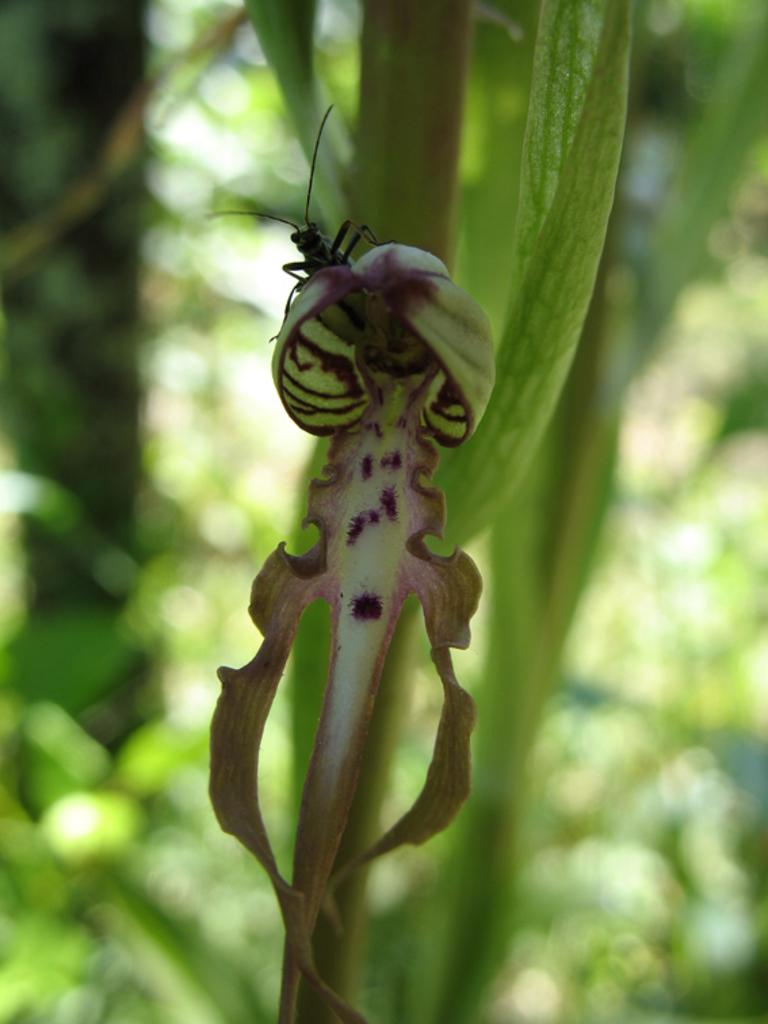What is present on the leaf in the image? There is an insect on the leaf in the image. What type of leaf is visible in the image? The fact does not specify the type of leaf, only that there is a leaf present. What color is the servant wearing in the image? There is no servant present in the image; it only features a leaf and an insect on it. 